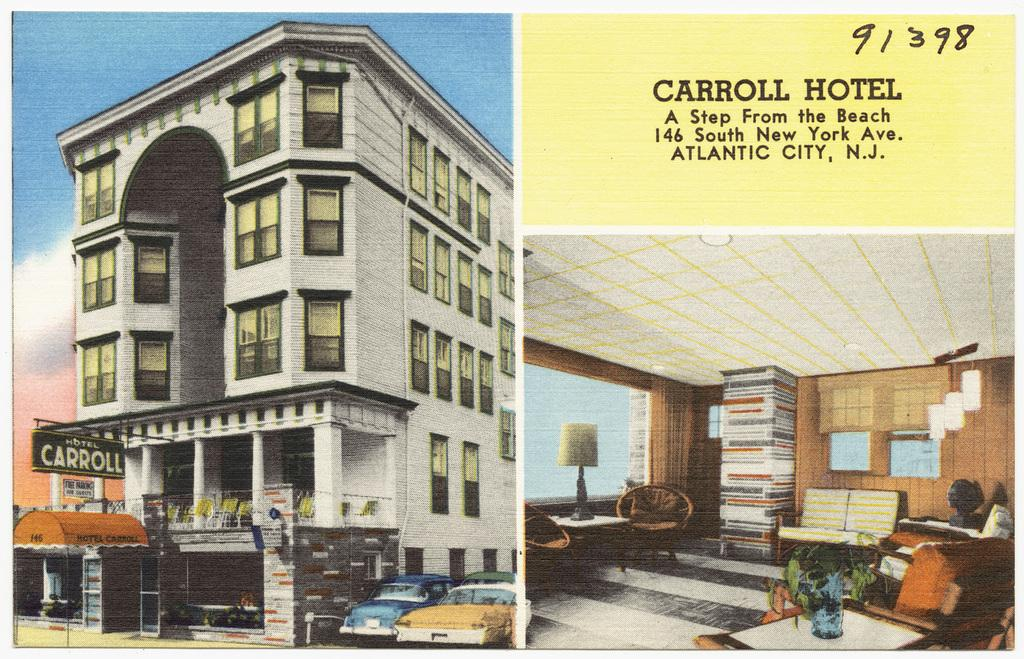<image>
Provide a brief description of the given image. The hotel in the image is called the Carroll Hotel 